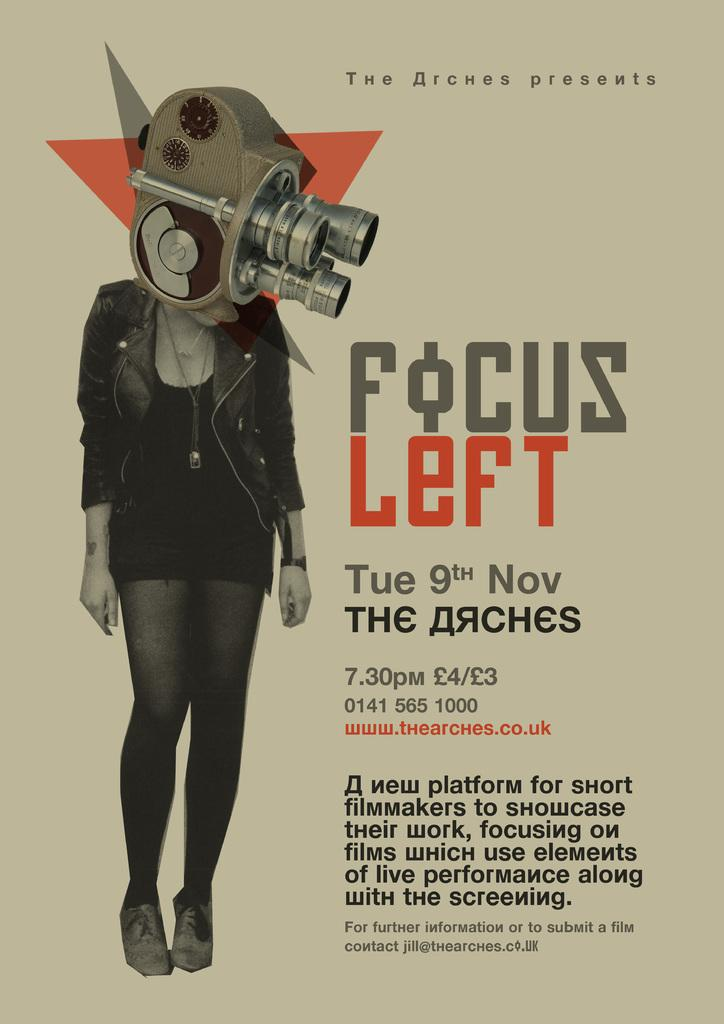<image>
Create a compact narrative representing the image presented. A poster for an event called Focus Left on the 9th of November. 